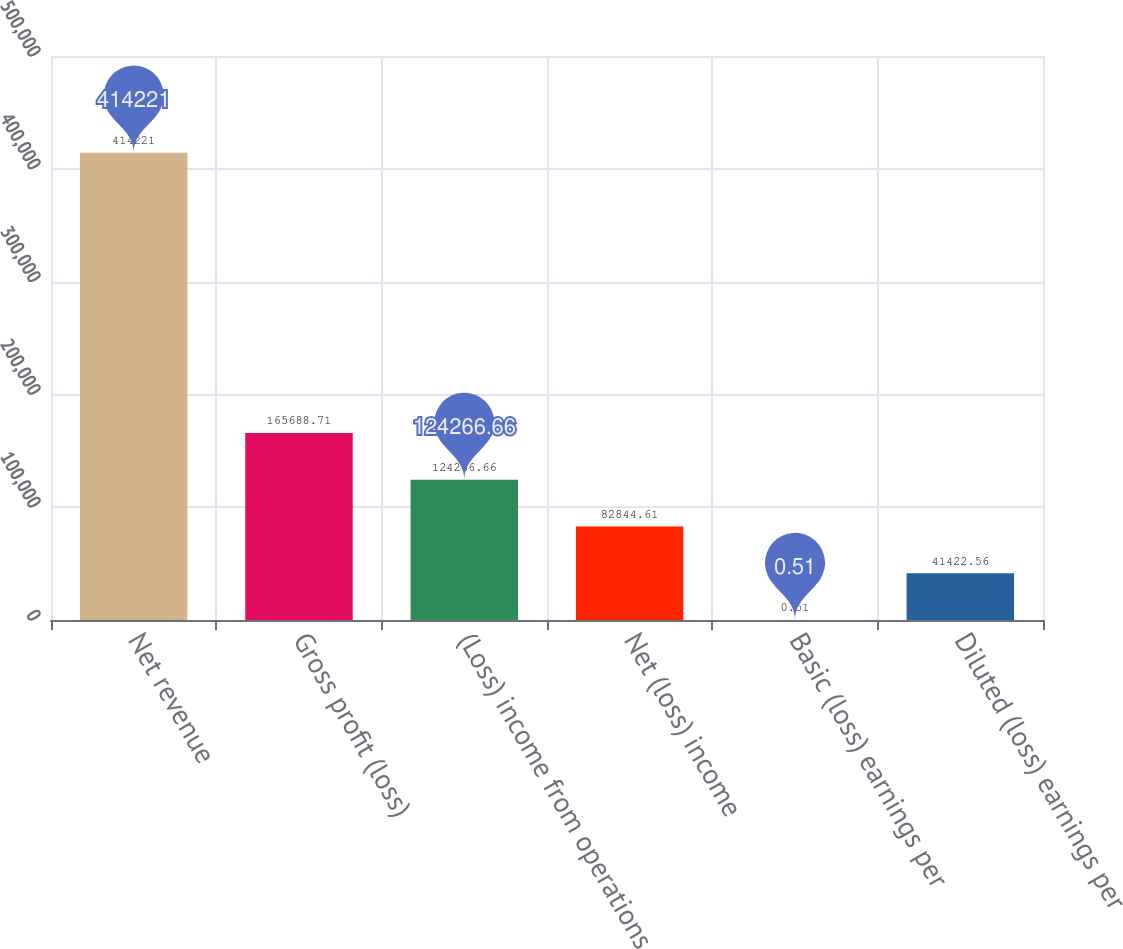<chart> <loc_0><loc_0><loc_500><loc_500><bar_chart><fcel>Net revenue<fcel>Gross profit (loss)<fcel>(Loss) income from operations<fcel>Net (loss) income<fcel>Basic (loss) earnings per<fcel>Diluted (loss) earnings per<nl><fcel>414221<fcel>165689<fcel>124267<fcel>82844.6<fcel>0.51<fcel>41422.6<nl></chart> 